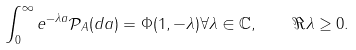<formula> <loc_0><loc_0><loc_500><loc_500>\int _ { 0 } ^ { \infty } e ^ { - \lambda a } \mathcal { P } _ { A } ( d a ) = \Phi ( 1 , - \lambda ) \forall \lambda \in \mathbb { C } , \quad \Re \lambda \geq 0 .</formula> 